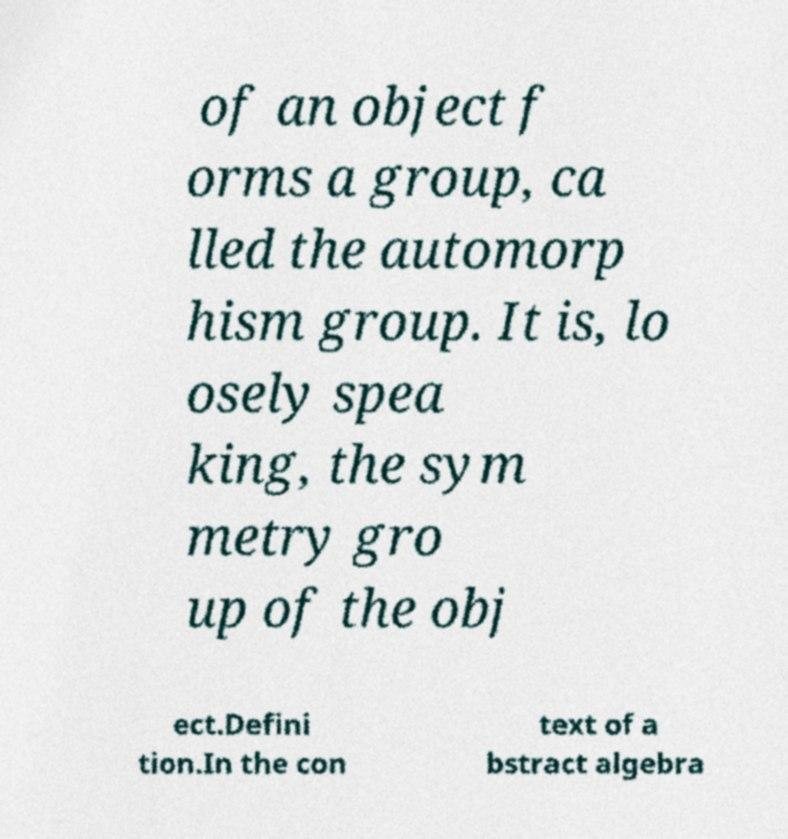I need the written content from this picture converted into text. Can you do that? of an object f orms a group, ca lled the automorp hism group. It is, lo osely spea king, the sym metry gro up of the obj ect.Defini tion.In the con text of a bstract algebra 